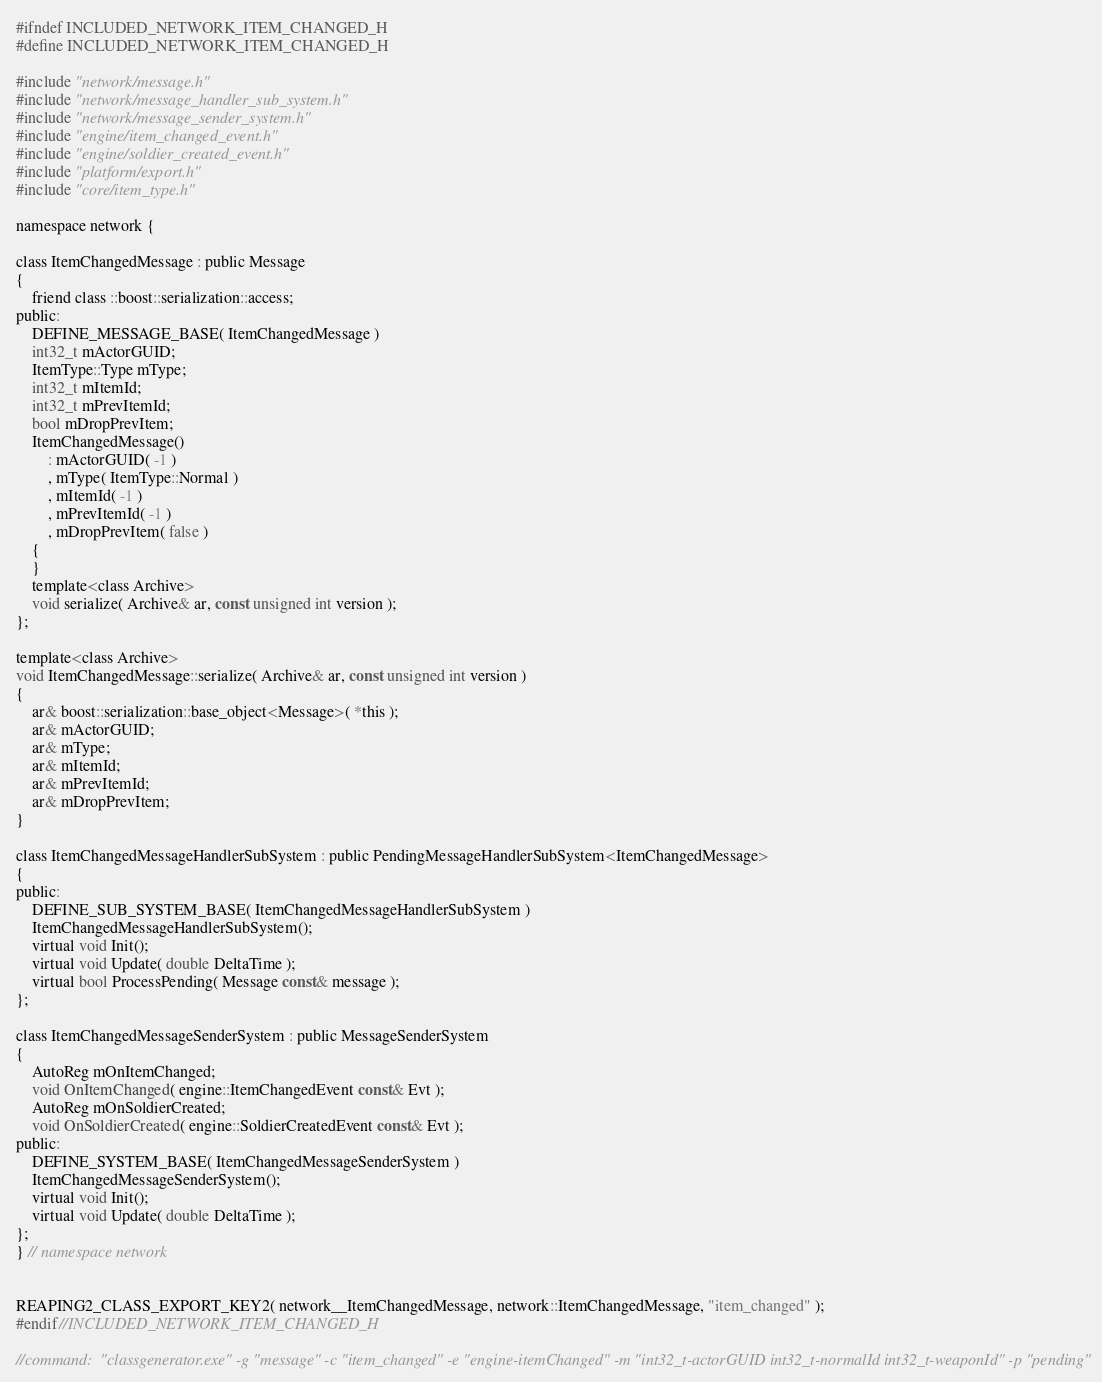<code> <loc_0><loc_0><loc_500><loc_500><_C_>#ifndef INCLUDED_NETWORK_ITEM_CHANGED_H
#define INCLUDED_NETWORK_ITEM_CHANGED_H

#include "network/message.h"
#include "network/message_handler_sub_system.h"
#include "network/message_sender_system.h"
#include "engine/item_changed_event.h"
#include "engine/soldier_created_event.h"
#include "platform/export.h"
#include "core/item_type.h"

namespace network {

class ItemChangedMessage : public Message
{
    friend class ::boost::serialization::access;
public:
    DEFINE_MESSAGE_BASE( ItemChangedMessage )
    int32_t mActorGUID;
    ItemType::Type mType;
    int32_t mItemId;
    int32_t mPrevItemId;
    bool mDropPrevItem;
    ItemChangedMessage()
        : mActorGUID( -1 )
        , mType( ItemType::Normal )
        , mItemId( -1 )
        , mPrevItemId( -1 )
        , mDropPrevItem( false )
    {
    }
    template<class Archive>
    void serialize( Archive& ar, const unsigned int version );
};

template<class Archive>
void ItemChangedMessage::serialize( Archive& ar, const unsigned int version )
{
    ar& boost::serialization::base_object<Message>( *this );
    ar& mActorGUID;
    ar& mType;
    ar& mItemId;
    ar& mPrevItemId;
    ar& mDropPrevItem;
}

class ItemChangedMessageHandlerSubSystem : public PendingMessageHandlerSubSystem<ItemChangedMessage>
{
public:
    DEFINE_SUB_SYSTEM_BASE( ItemChangedMessageHandlerSubSystem )
    ItemChangedMessageHandlerSubSystem();
    virtual void Init();
    virtual void Update( double DeltaTime );
    virtual bool ProcessPending( Message const& message );
};

class ItemChangedMessageSenderSystem : public MessageSenderSystem
{
    AutoReg mOnItemChanged;
    void OnItemChanged( engine::ItemChangedEvent const& Evt );
    AutoReg mOnSoldierCreated;
    void OnSoldierCreated( engine::SoldierCreatedEvent const& Evt );
public:
    DEFINE_SYSTEM_BASE( ItemChangedMessageSenderSystem )
    ItemChangedMessageSenderSystem();
    virtual void Init();
    virtual void Update( double DeltaTime );
};
} // namespace network


REAPING2_CLASS_EXPORT_KEY2( network__ItemChangedMessage, network::ItemChangedMessage, "item_changed" );
#endif//INCLUDED_NETWORK_ITEM_CHANGED_H

//command:  "classgenerator.exe" -g "message" -c "item_changed" -e "engine-itemChanged" -m "int32_t-actorGUID int32_t-normalId int32_t-weaponId" -p "pending"
</code> 